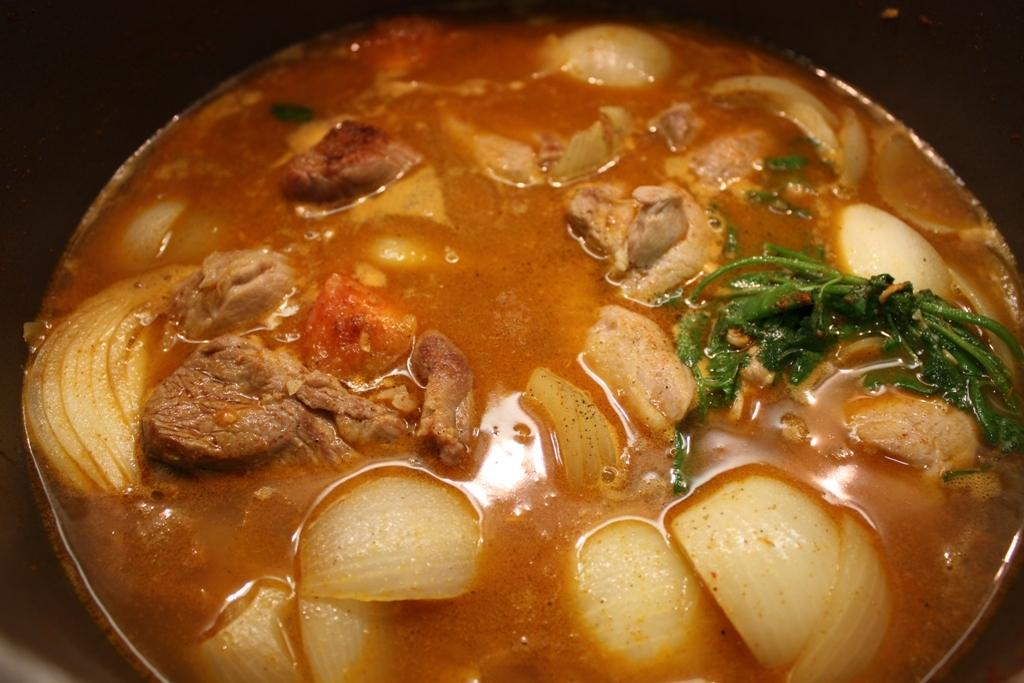What is the main subject in the image? There is a food item in a bowl in the image. What type of parenting advice can be seen in the image? There is no parenting advice present in the image; it features a food item in a bowl. What thoughts or ideas can be seen in the image? There are no thoughts or ideas visible in the image; it features a food item in a bowl. 